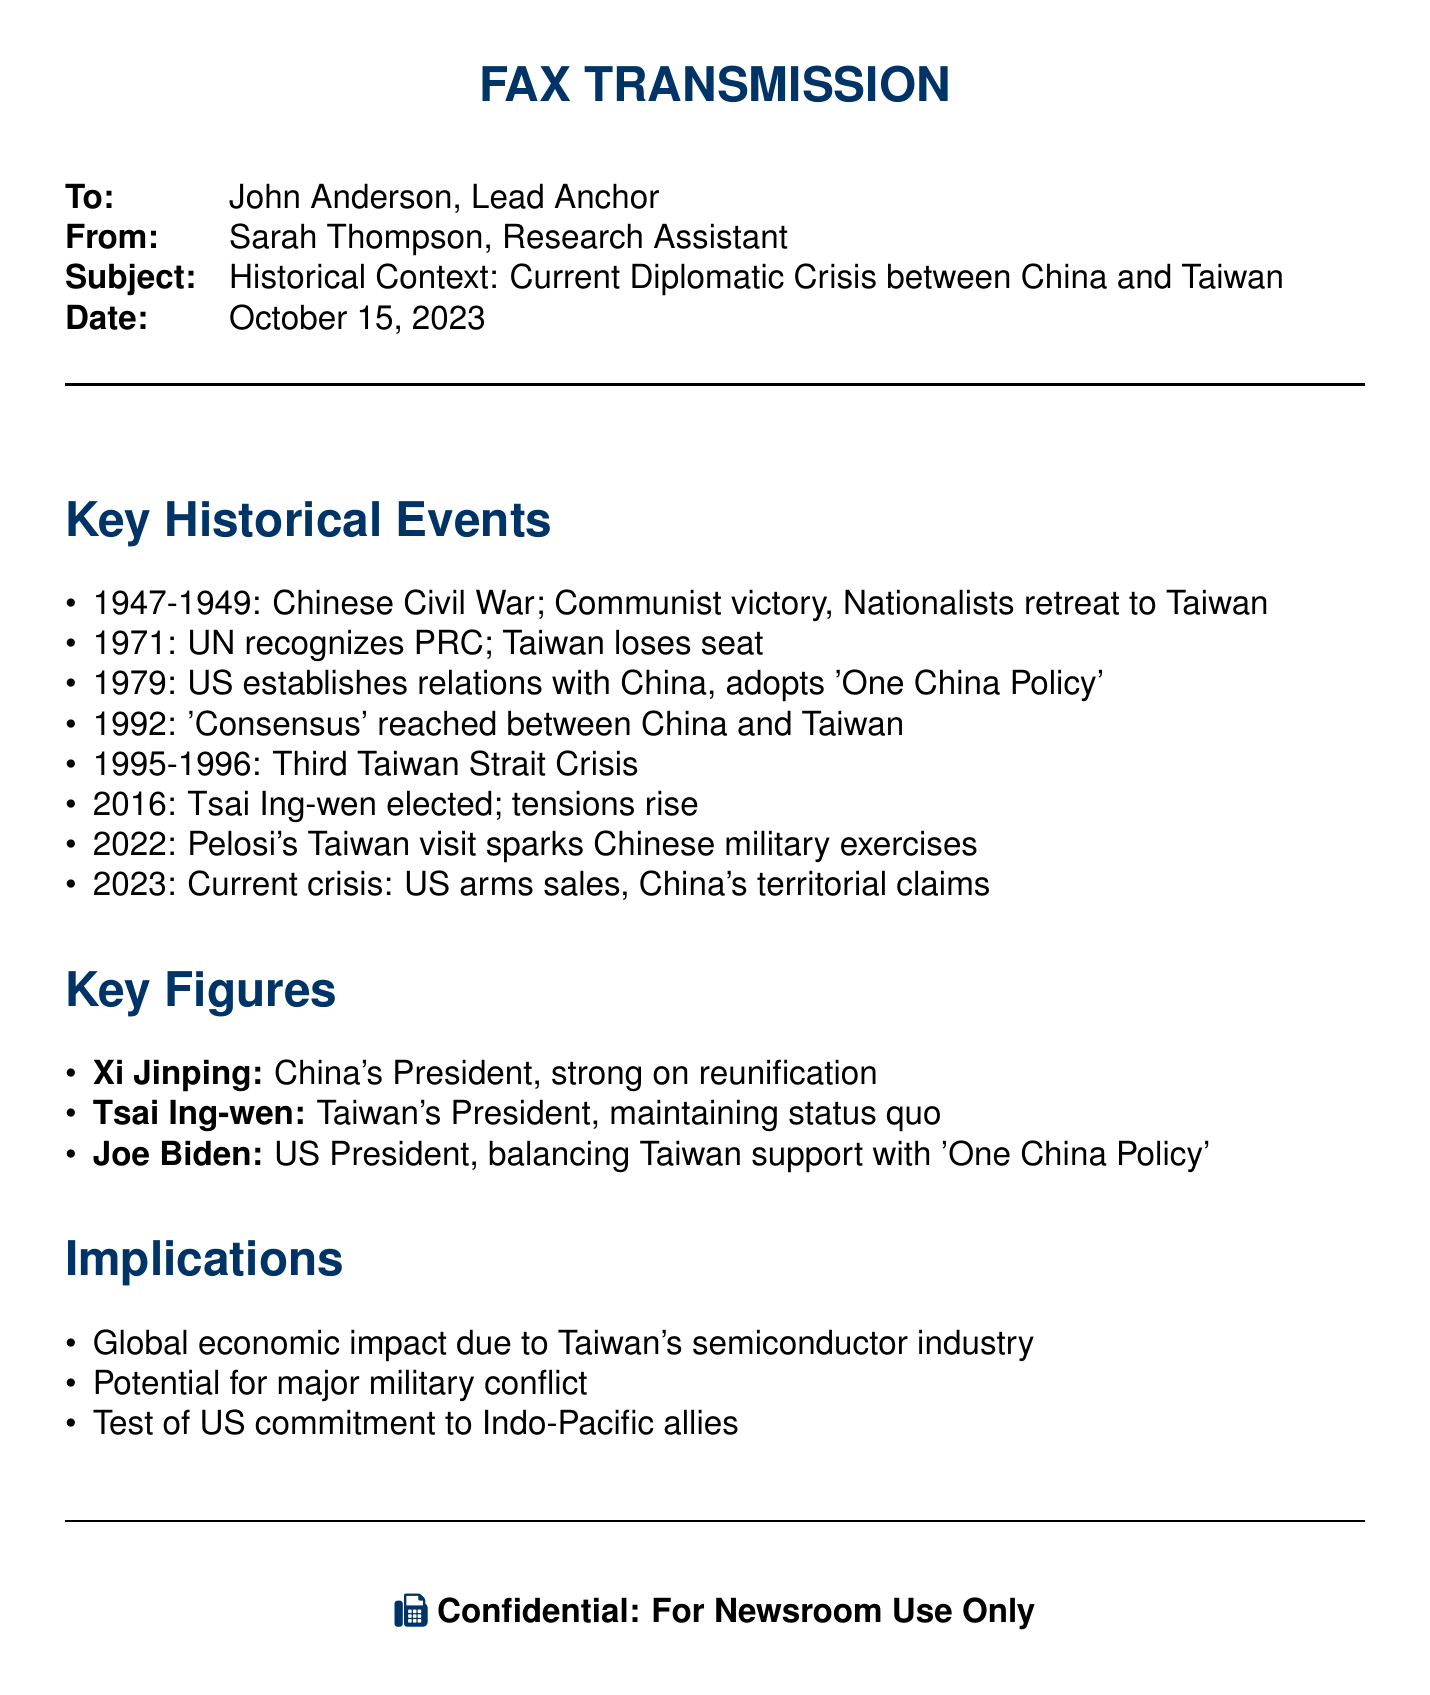What year did the Chinese Civil War end? The document states the period of the Chinese Civil War was from 1947 to 1949, indicating it ended in 1949.
Answer: 1949 Who was elected as Taiwan's President in 2016? The document mentions Tsai Ing-wen being elected as Taiwan's President in 2016.
Answer: Tsai Ing-wen What significant event occurred in 1971 regarding Taiwan's UN status? According to the document, in 1971, the UN recognized the People's Republic of China, leading to Taiwan losing its seat.
Answer: Taiwan loses seat Which crisis is referred to between 1995 and 1996? The document identifies the Third Taiwan Strait Crisis occurring during the years 1995-1996.
Answer: Third Taiwan Strait Crisis Who is noted as the strong proponent of reunification in China? The document lists Xi Jinping as China's President and a strong advocate for reunification.
Answer: Xi Jinping What does the document suggest could be a global consequence of the current Taiwan crisis? It indicates that the global economic impact is influenced due to Taiwan's semiconductor industry.
Answer: Global economic impact What does the current crisis test regarding the U.S.? The document mentions it tests the U.S. commitment to Indo-Pacific allies in relation to the crisis.
Answer: US commitment What is the relationship policy adopted by the US in 1979? The document states that in 1979, the US established relations and adopted the 'One China Policy.'
Answer: One China Policy 